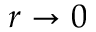<formula> <loc_0><loc_0><loc_500><loc_500>r \to 0</formula> 